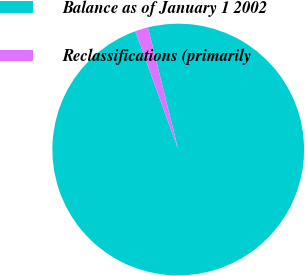Convert chart to OTSL. <chart><loc_0><loc_0><loc_500><loc_500><pie_chart><fcel>Balance as of January 1 2002<fcel>Reclassifications (primarily<nl><fcel>98.33%<fcel>1.67%<nl></chart> 